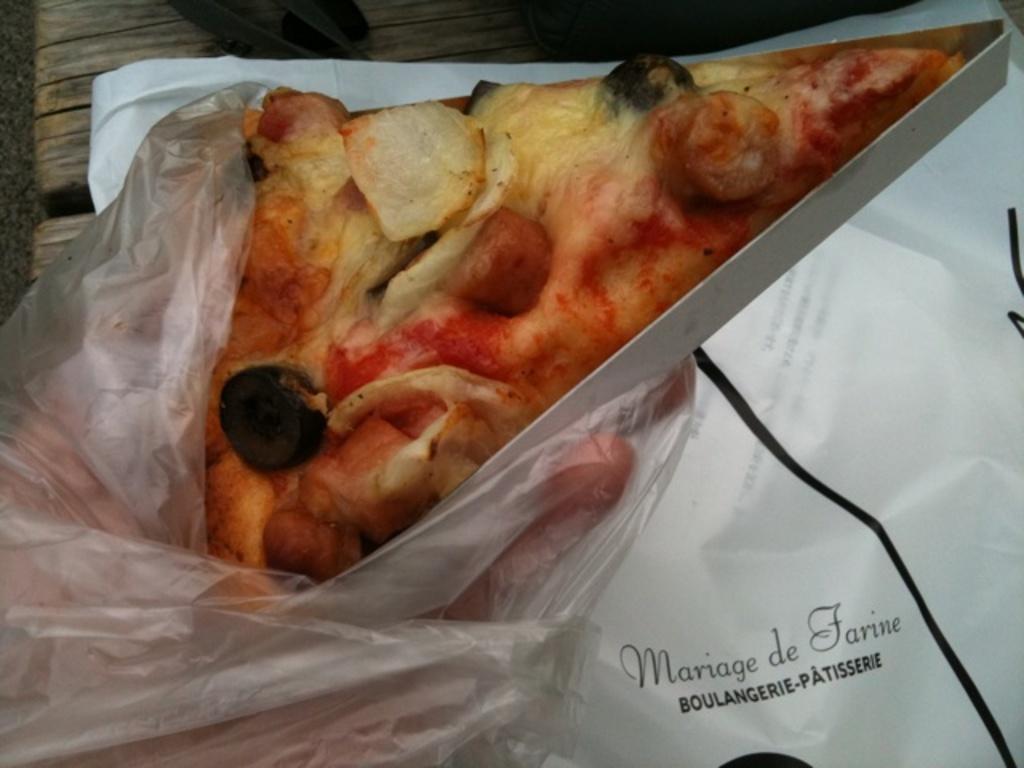Please provide a concise description of this image. In this image we can see a pizza in the hand of a person. We can also see a cover to his hand. On the backside we can see a cover with some text on it which is placed on the surface. 